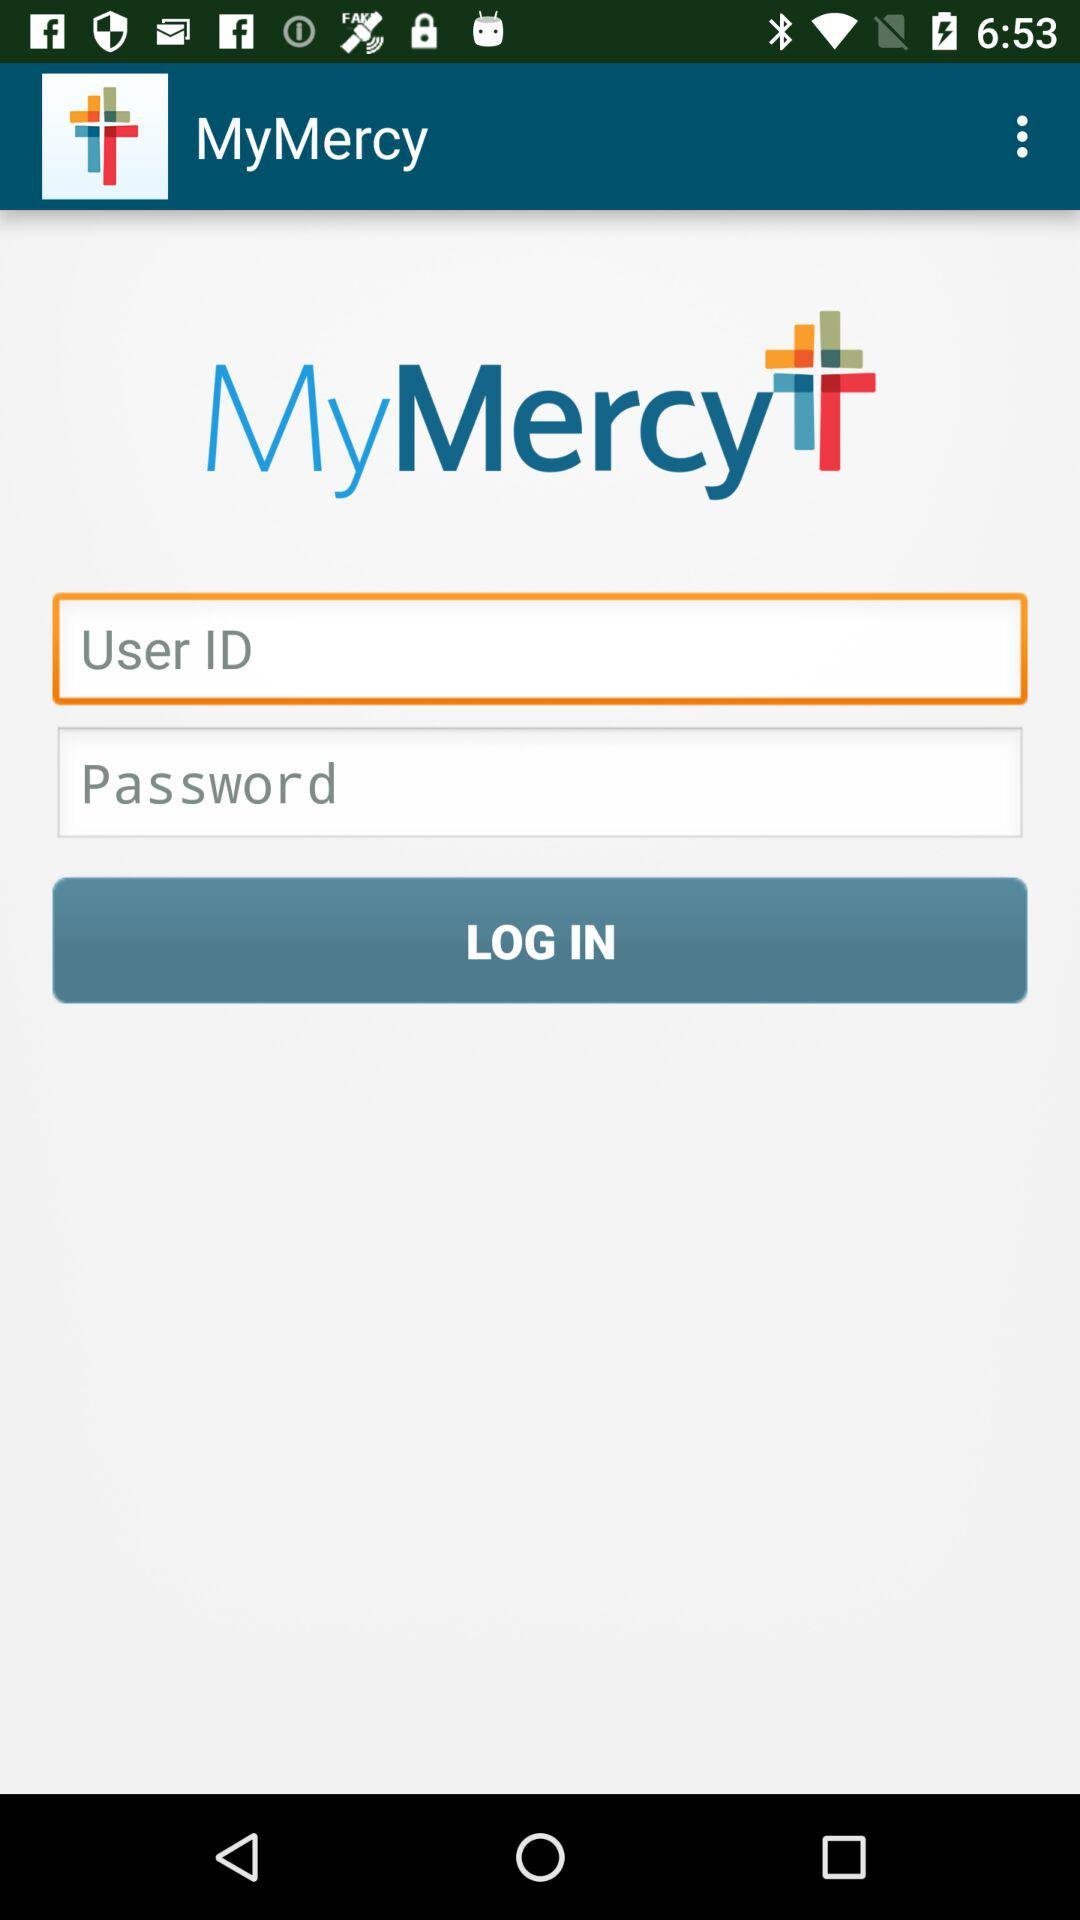How many fields are there to enter credentials?
Answer the question using a single word or phrase. 2 